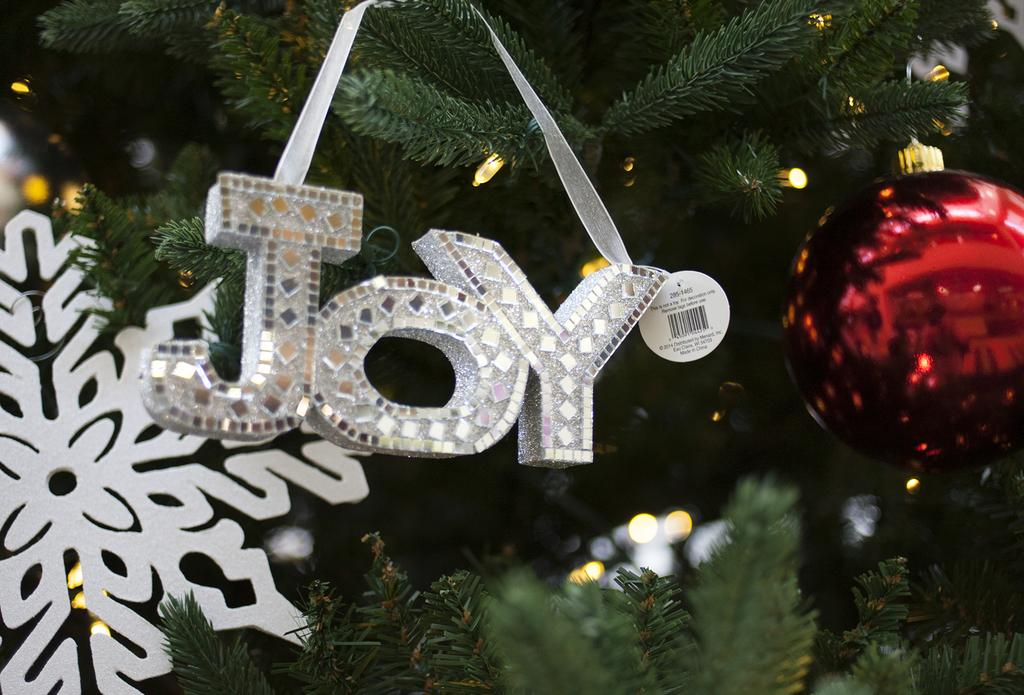What is the main subject of the image? There is a Christmas tree in the image. How is the Christmas tree adorned? The Christmas tree is decorated. What type of celery can be seen growing around the Christmas tree in the image? There is no celery present in the image; it features a decorated Christmas tree. What type of sail can be seen attached to the Christmas tree in the image? There is no sail present in the image; it features a decorated Christmas tree. 